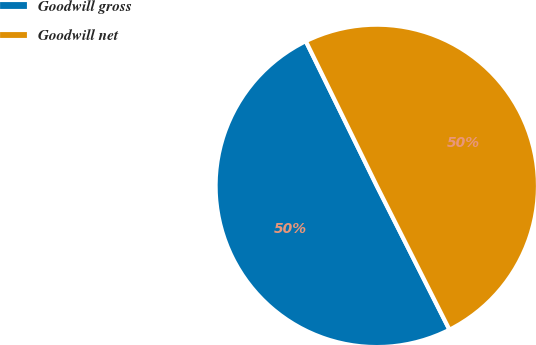<chart> <loc_0><loc_0><loc_500><loc_500><pie_chart><fcel>Goodwill gross<fcel>Goodwill net<nl><fcel>50.19%<fcel>49.81%<nl></chart> 